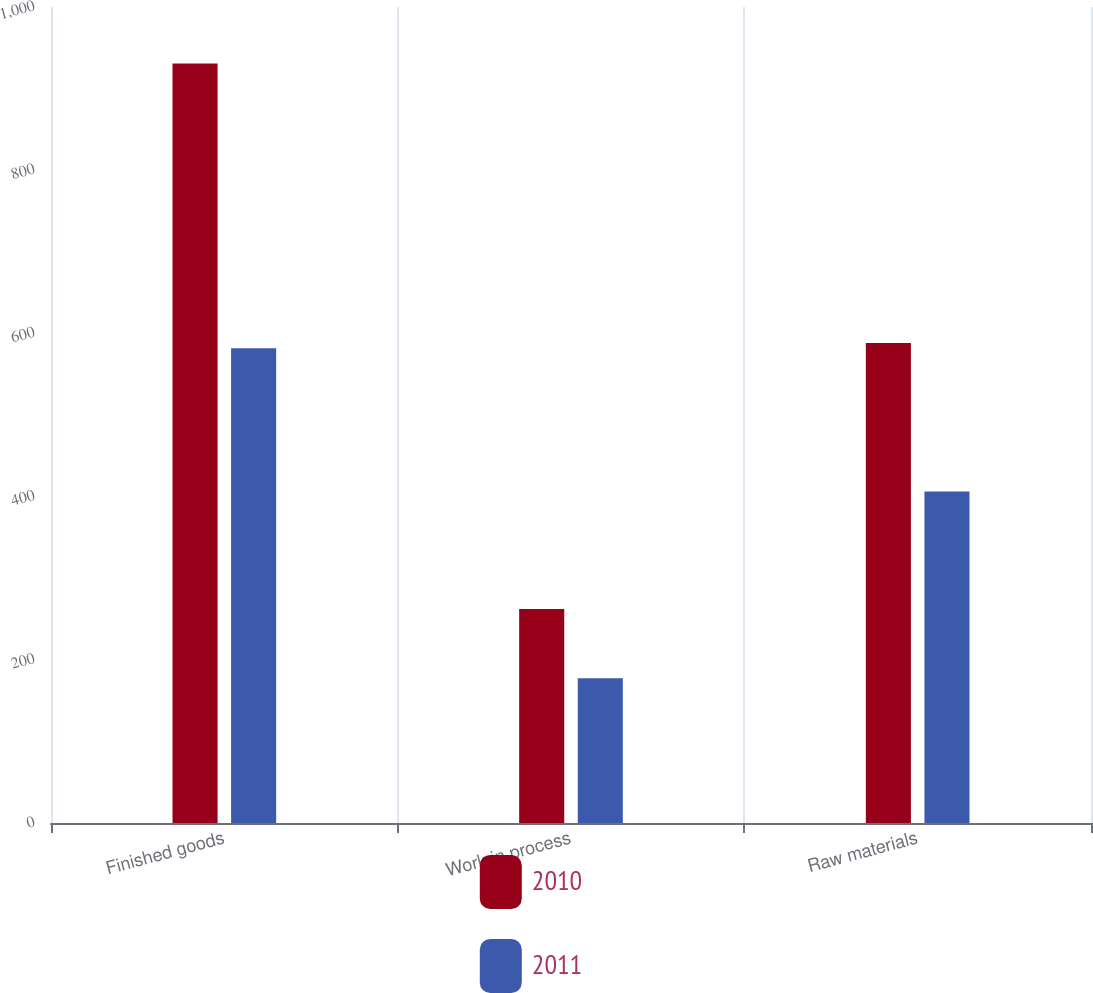<chart> <loc_0><loc_0><loc_500><loc_500><stacked_bar_chart><ecel><fcel>Finished goods<fcel>Work in process<fcel>Raw materials<nl><fcel>2010<fcel>930.9<fcel>262.2<fcel>588.3<nl><fcel>2011<fcel>581.8<fcel>177.5<fcel>406.3<nl></chart> 